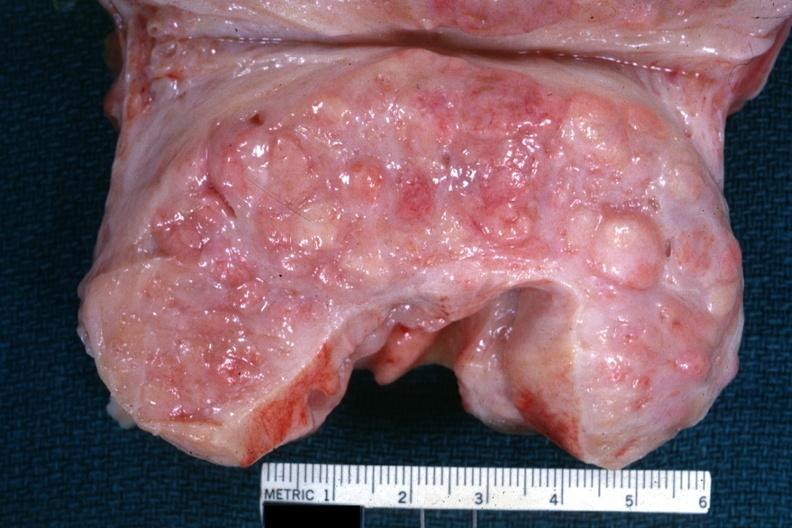what does this image show?
Answer the question using a single word or phrase. Excellent example cut surface with nodular hyperplasia 